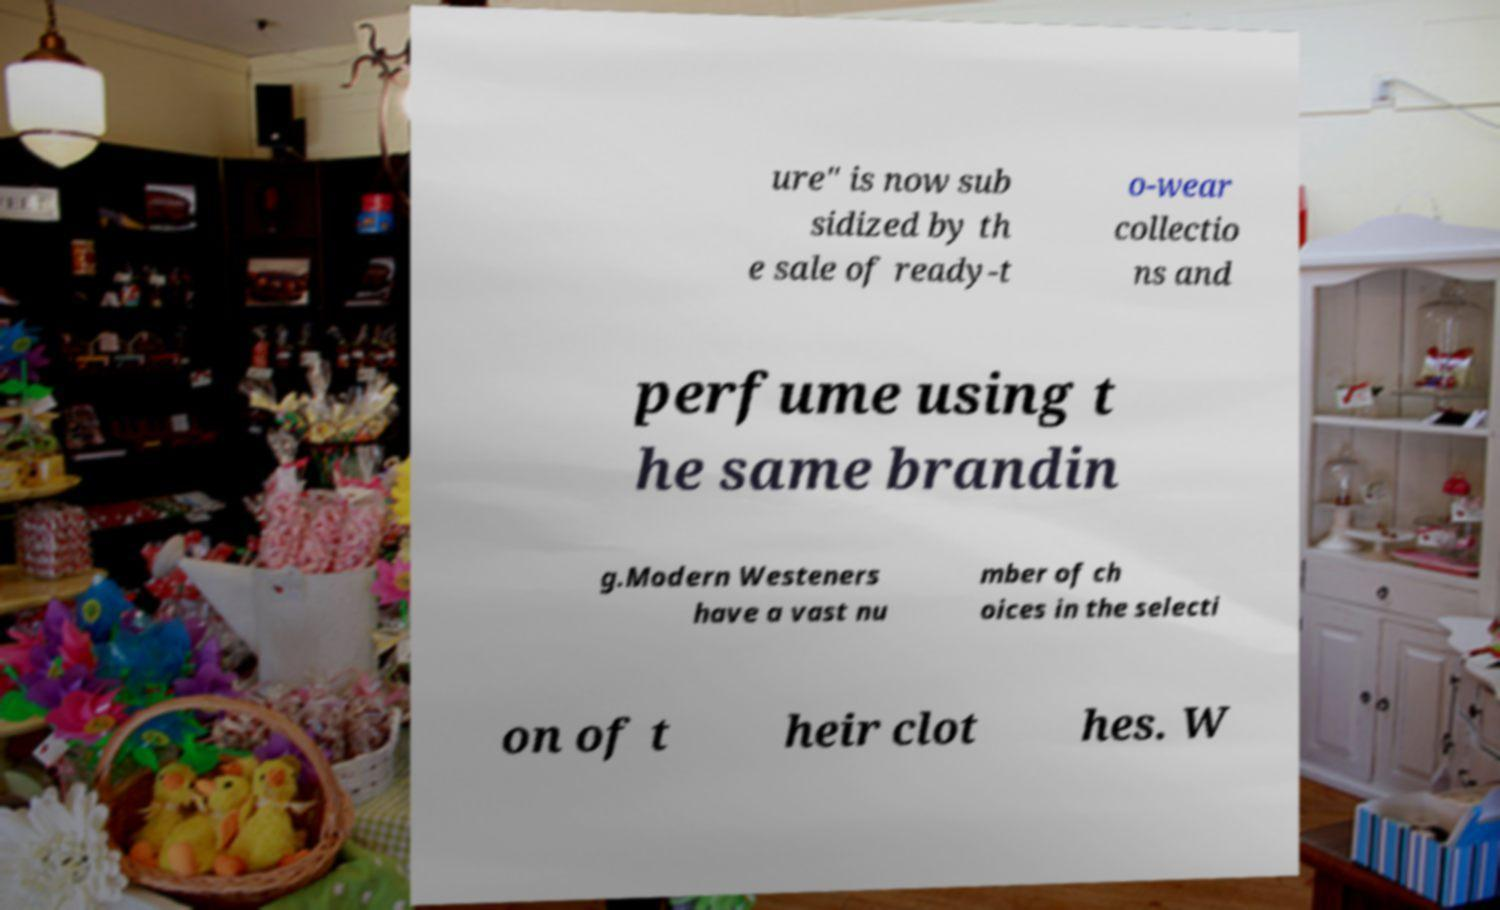Can you accurately transcribe the text from the provided image for me? ure" is now sub sidized by th e sale of ready-t o-wear collectio ns and perfume using t he same brandin g.Modern Westeners have a vast nu mber of ch oices in the selecti on of t heir clot hes. W 